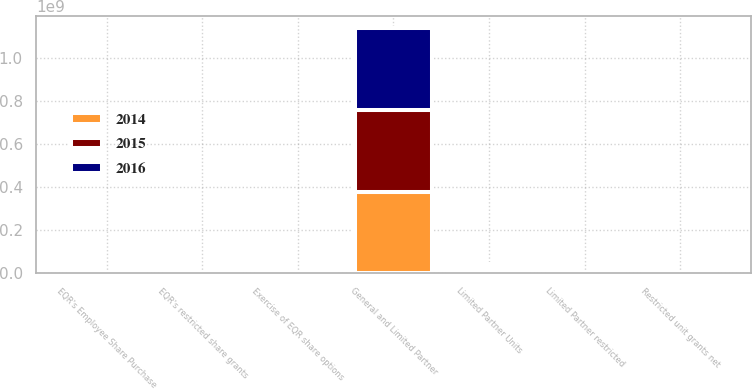Convert chart to OTSL. <chart><loc_0><loc_0><loc_500><loc_500><stacked_bar_chart><ecel><fcel>General and Limited Partner<fcel>Exercise of EQR share options<fcel>EQR's Employee Share Purchase<fcel>EQR's restricted share grants<fcel>Restricted unit grants net<fcel>Limited Partner Units<fcel>Limited Partner restricted<nl><fcel>2016<fcel>3.80497e+08<fcel>815044<fcel>63909<fcel>147689<fcel>287749<fcel>1.44272e+07<fcel>287749<nl><fcel>2015<fcel>3.79183e+08<fcel>1.45636e+06<fcel>68462<fcel>168142<fcel>335496<fcel>1.42987e+07<fcel>335496<nl><fcel>2014<fcel>3.77154e+08<fcel>2.08638e+06<fcel>68807<fcel>169722<fcel>200840<fcel>1.41804e+07<fcel>200840<nl></chart> 